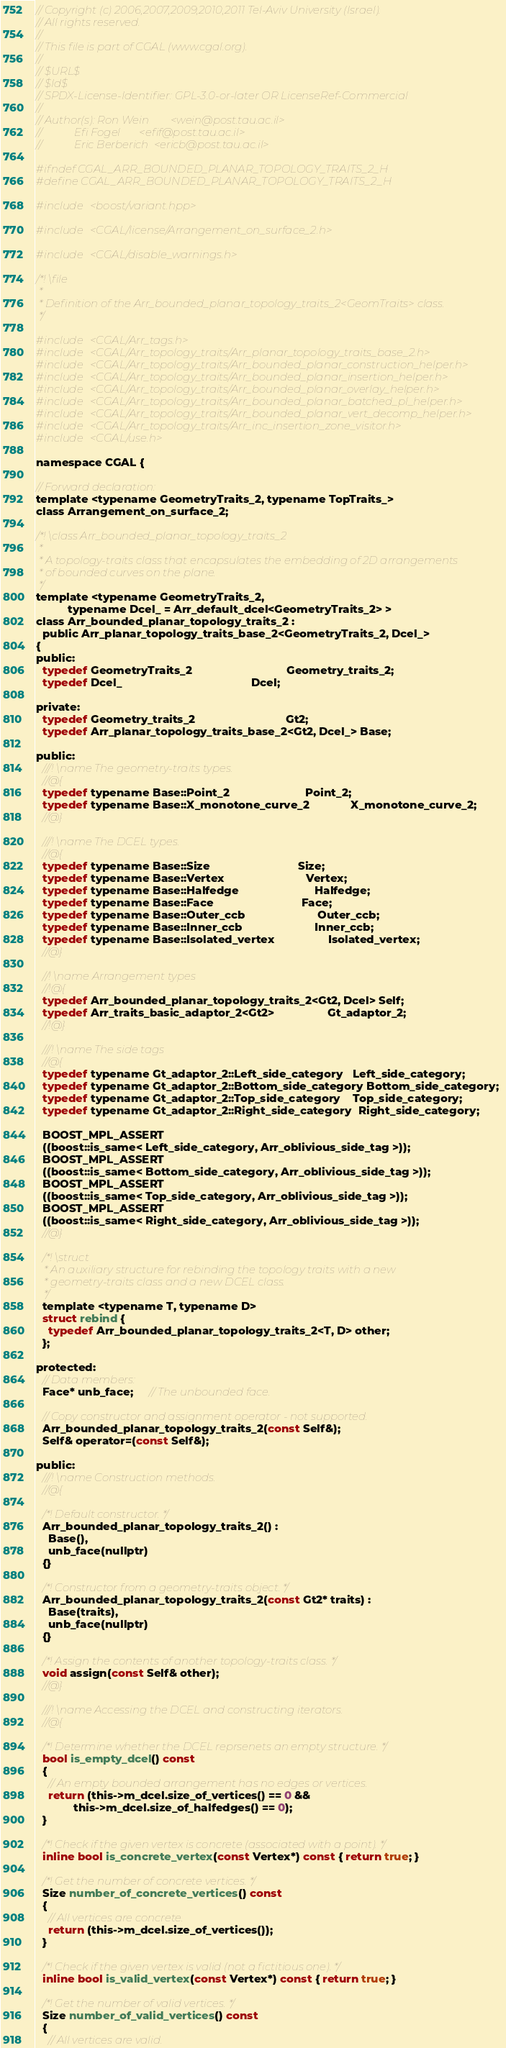Convert code to text. <code><loc_0><loc_0><loc_500><loc_500><_C_>// Copyright (c) 2006,2007,2009,2010,2011 Tel-Aviv University (Israel).
// All rights reserved.
//
// This file is part of CGAL (www.cgal.org).
//
// $URL$
// $Id$
// SPDX-License-Identifier: GPL-3.0-or-later OR LicenseRef-Commercial
//
// Author(s): Ron Wein        <wein@post.tau.ac.il>
//            Efi Fogel       <efif@post.tau.ac.il>
//            Eric Berberich  <ericb@post.tau.ac.il>

#ifndef CGAL_ARR_BOUNDED_PLANAR_TOPOLOGY_TRAITS_2_H
#define CGAL_ARR_BOUNDED_PLANAR_TOPOLOGY_TRAITS_2_H

#include <boost/variant.hpp>

#include <CGAL/license/Arrangement_on_surface_2.h>

#include <CGAL/disable_warnings.h>

/*! \file
 *
 * Definition of the Arr_bounded_planar_topology_traits_2<GeomTraits> class.
 */

#include <CGAL/Arr_tags.h>
#include <CGAL/Arr_topology_traits/Arr_planar_topology_traits_base_2.h>
#include <CGAL/Arr_topology_traits/Arr_bounded_planar_construction_helper.h>
#include <CGAL/Arr_topology_traits/Arr_bounded_planar_insertion_helper.h>
#include <CGAL/Arr_topology_traits/Arr_bounded_planar_overlay_helper.h>
#include <CGAL/Arr_topology_traits/Arr_bounded_planar_batched_pl_helper.h>
#include <CGAL/Arr_topology_traits/Arr_bounded_planar_vert_decomp_helper.h>
#include <CGAL/Arr_topology_traits/Arr_inc_insertion_zone_visitor.h>
#include <CGAL/use.h>

namespace CGAL {

// Forward declaration:
template <typename GeometryTraits_2, typename TopTraits_>
class Arrangement_on_surface_2;

/*! \class Arr_bounded_planar_topology_traits_2
 *
 * A topology-traits class that encapsulates the embedding of 2D arrangements
 * of bounded curves on the plane.
 */
template <typename GeometryTraits_2,
          typename Dcel_ = Arr_default_dcel<GeometryTraits_2> >
class Arr_bounded_planar_topology_traits_2 :
  public Arr_planar_topology_traits_base_2<GeometryTraits_2, Dcel_>
{
public:
  typedef GeometryTraits_2                              Geometry_traits_2;
  typedef Dcel_                                         Dcel;

private:
  typedef Geometry_traits_2                             Gt2;
  typedef Arr_planar_topology_traits_base_2<Gt2, Dcel_> Base;

public:
  ///! \name The geometry-traits types.
  //@{
  typedef typename Base::Point_2                        Point_2;
  typedef typename Base::X_monotone_curve_2             X_monotone_curve_2;
  //@}

  ///! \name The DCEL types.
  //@{
  typedef typename Base::Size                            Size;
  typedef typename Base::Vertex                          Vertex;
  typedef typename Base::Halfedge                        Halfedge;
  typedef typename Base::Face                            Face;
  typedef typename Base::Outer_ccb                       Outer_ccb;
  typedef typename Base::Inner_ccb                       Inner_ccb;
  typedef typename Base::Isolated_vertex                 Isolated_vertex;
  //@}

  //! \name Arrangement types
  //!@{
  typedef Arr_bounded_planar_topology_traits_2<Gt2, Dcel> Self;
  typedef Arr_traits_basic_adaptor_2<Gt2>                 Gt_adaptor_2;
  //!@}

  ///! \name The side tags
  //@{
  typedef typename Gt_adaptor_2::Left_side_category   Left_side_category;
  typedef typename Gt_adaptor_2::Bottom_side_category Bottom_side_category;
  typedef typename Gt_adaptor_2::Top_side_category    Top_side_category;
  typedef typename Gt_adaptor_2::Right_side_category  Right_side_category;

  BOOST_MPL_ASSERT
  ((boost::is_same< Left_side_category, Arr_oblivious_side_tag >));
  BOOST_MPL_ASSERT
  ((boost::is_same< Bottom_side_category, Arr_oblivious_side_tag >));
  BOOST_MPL_ASSERT
  ((boost::is_same< Top_side_category, Arr_oblivious_side_tag >));
  BOOST_MPL_ASSERT
  ((boost::is_same< Right_side_category, Arr_oblivious_side_tag >));
  //@}

  /*! \struct
   * An auxiliary structure for rebinding the topology traits with a new
   * geometry-traits class and a new DCEL class.
   */
  template <typename T, typename D>
  struct rebind {
    typedef Arr_bounded_planar_topology_traits_2<T, D> other;
  };

protected:
  // Data members:
  Face* unb_face;     // The unbounded face.

  // Copy constructor and assignment operator - not supported.
  Arr_bounded_planar_topology_traits_2(const Self&);
  Self& operator=(const Self&);

public:
  ///! \name Construction methods.
  //@{

  /*! Default constructor. */
  Arr_bounded_planar_topology_traits_2() :
    Base(),
    unb_face(nullptr)
  {}

  /*! Constructor from a geometry-traits object. */
  Arr_bounded_planar_topology_traits_2(const Gt2* traits) :
    Base(traits),
    unb_face(nullptr)
  {}

  /*! Assign the contents of another topology-traits class. */
  void assign(const Self& other);
  //@}

  ///! \name Accessing the DCEL and constructing iterators.
  //@{

  /*! Determine whether the DCEL reprsenets an empty structure. */
  bool is_empty_dcel() const
  {
    // An empty bounded arrangement has no edges or vertices.
    return (this->m_dcel.size_of_vertices() == 0 &&
            this->m_dcel.size_of_halfedges() == 0);
  }

  /*! Check if the given vertex is concrete (associated with a point). */
  inline bool is_concrete_vertex(const Vertex*) const { return true; }

  /*! Get the number of concrete vertices. */
  Size number_of_concrete_vertices() const
  {
    // All vertices are concrete.
    return (this->m_dcel.size_of_vertices());
  }

  /*! Check if the given vertex is valid (not a fictitious one). */
  inline bool is_valid_vertex(const Vertex*) const { return true; }

  /*! Get the number of valid vertices. */
  Size number_of_valid_vertices() const
  {
    // All vertices are valid.</code> 